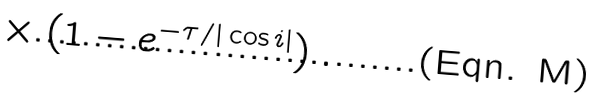Convert formula to latex. <formula><loc_0><loc_0><loc_500><loc_500>\times \left ( 1 - e ^ { - \tau / | \cos { i } | } \right ) .</formula> 